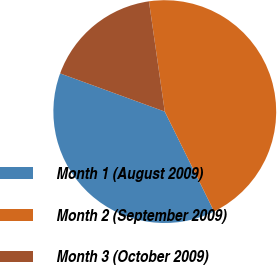Convert chart to OTSL. <chart><loc_0><loc_0><loc_500><loc_500><pie_chart><fcel>Month 1 (August 2009)<fcel>Month 2 (September 2009)<fcel>Month 3 (October 2009)<nl><fcel>37.87%<fcel>44.97%<fcel>17.16%<nl></chart> 